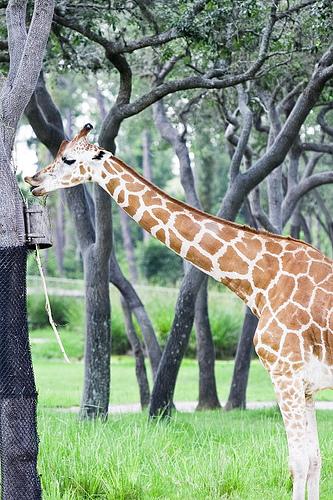What is the giraffe eating out of?
Answer briefly. Feeder. What is this animal eating?
Concise answer only. Leaves. Is this animal an elephant?
Give a very brief answer. No. Is something wrapped around the tree trunk?
Keep it brief. Yes. 